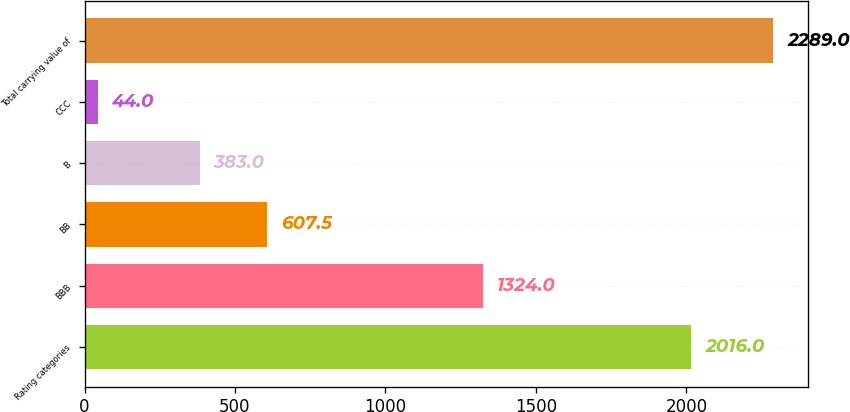Convert chart to OTSL. <chart><loc_0><loc_0><loc_500><loc_500><bar_chart><fcel>Rating categories<fcel>BBB<fcel>BB<fcel>B<fcel>CCC<fcel>Total carrying value of<nl><fcel>2016<fcel>1324<fcel>607.5<fcel>383<fcel>44<fcel>2289<nl></chart> 